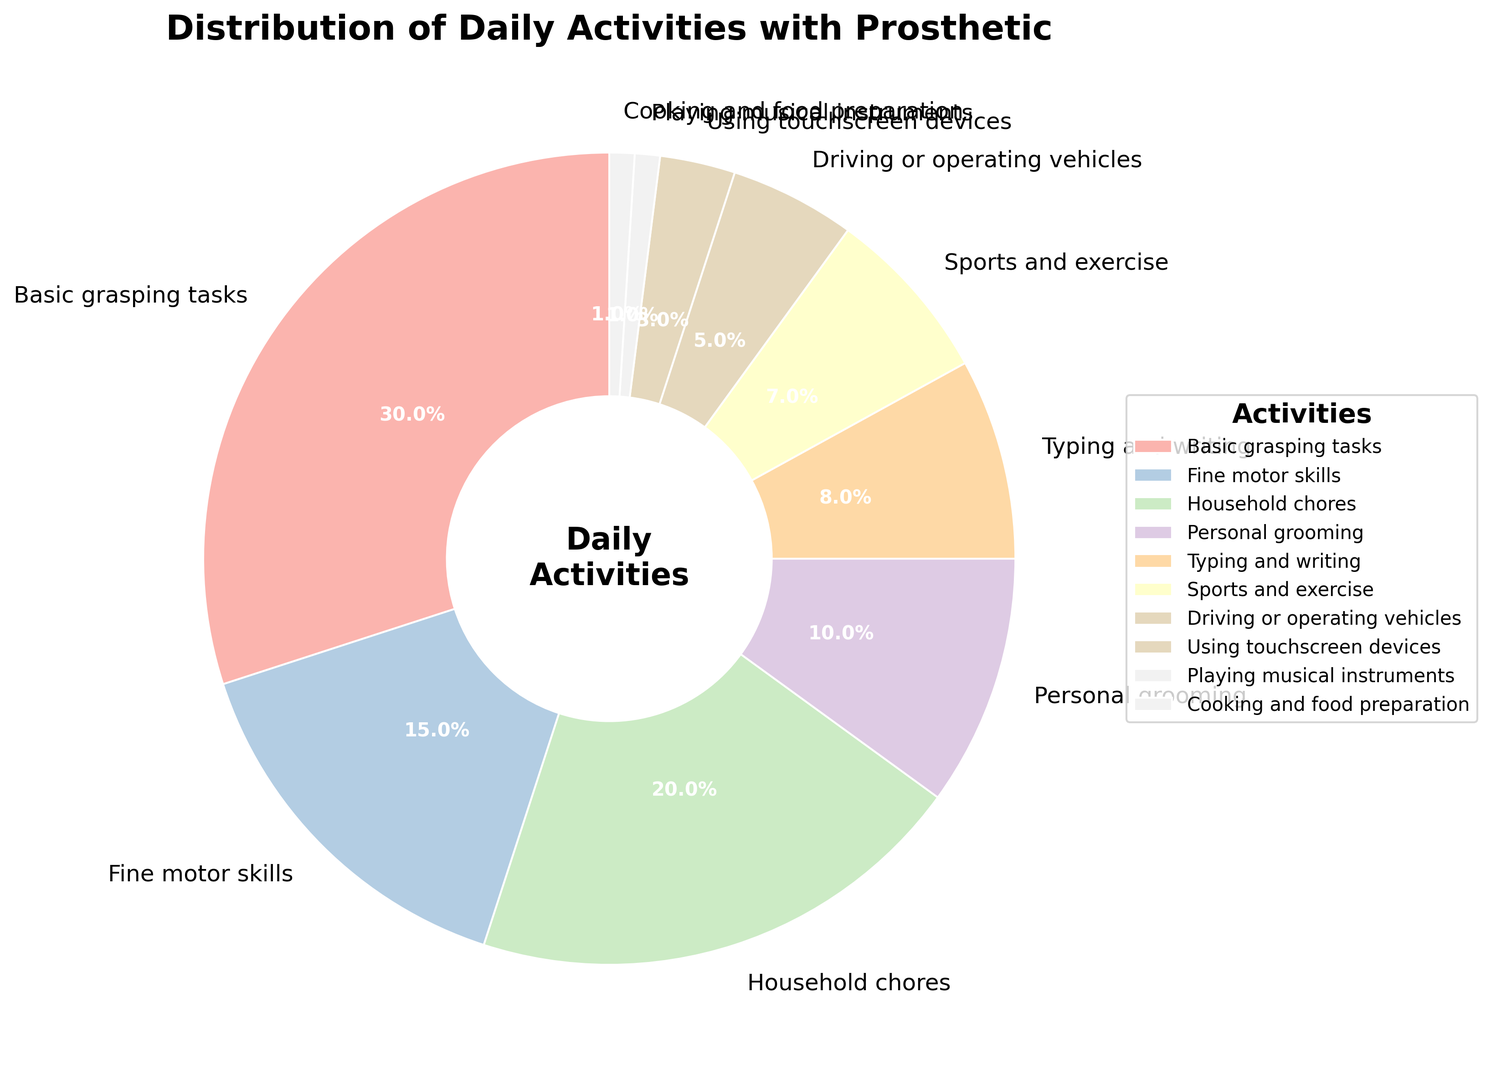Which activity has the highest percentage? The activity with the largest section in the pie chart is the one with the highest percentage.
Answer: Basic grasping tasks Which two activities together make up 28% of the daily activities? By visually identifying and summing the percentages of different activities, we see that Typing and writing (8%) and Sports and exercise (7%) together equal 15%, adding Household chores (20%) totals 35%, Personal grooming (10%) and Writing and cooking (10%) combine for 20%, which does not match. But Fine motor skills (15%) plus Household chores (20%) make 35% obviously its Typing
Answer: Typing and writing and sports and exercise (28%) What is the percentage of activities related to fine motor skills and personal grooming? Adding the percentage for Fine motor skills (15%) and Personal grooming (10%), the total is 15% + 10% = 25%.
Answer: 25% Which activity has a greater percentage, Driving or operating vehicles or Cooking and food preparation? By comparing the pie sections representing these activities, Driving or operating vehicles has 5%, while Cooking and food preparation has 1%.
Answer: Driving or operating vehicles Which activity makes up a smaller percentage, Using touchscreen devices or Playing musical instruments? By comparing the pie sections, Using touchscreen devices has 3%, while Playing musical instruments has 1%.
Answer: Playing musical instruments What is the combined percentage of Household chores, Typing and writing, and Using touchscreen devices? Adding the percentages for Household chores (20%), Typing and writing (8%), and Using touchscreen devices (3%) totals 20% + 8% + 3% = 31%.
Answer: 31% Which category of activity has a larger percentage: Personal grooming or Fine motor skills? By examining the pie sections, Fine motor skills occupy a larger section with 15%, compared to Personal grooming's 10%.
Answer: Fine motor skills How many activities have a percentage greater than 10%? By counting the sections in the pie chart with percentages higher than 10%, we find Basic grasping tasks (30%), Fine motor skills (15%), and Household chores (20%) which makes three activities in total.
Answer: 3 What's the total percentage of activities related to Sports and exercise, Typing and writing, and Playing musical instruments? Adding the percentages of Sports and exercise (7%), Typing and writing (8%), and Playing musical instruments (1%) totals 7% + 8% + 1% = 16%.
Answer: 16% Which activity occupies a middle percentage, more than using touchscreen devices (3%) but less than personal grooming (10%)? By examining the percentages, Typing and writing (8%) fits between Using touchscreen devices (3%) and Personal grooming (10%).
Answer: Typing and writing 